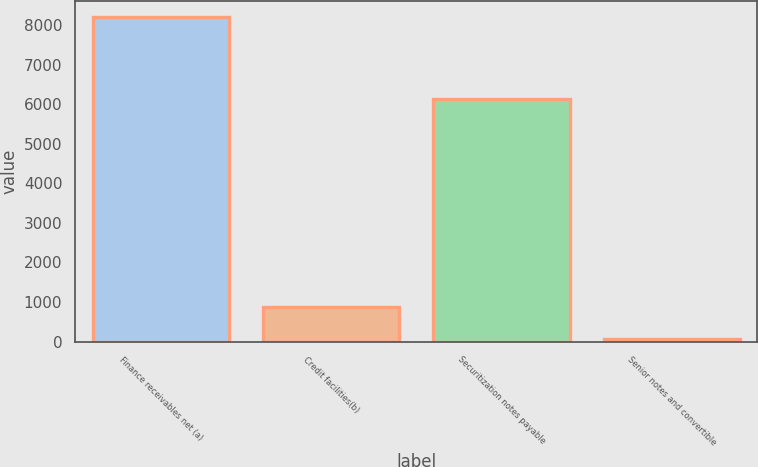Convert chart to OTSL. <chart><loc_0><loc_0><loc_500><loc_500><bar_chart><fcel>Finance receivables net (a)<fcel>Credit facilities(b)<fcel>Securitization notes payable<fcel>Senior notes and convertible<nl><fcel>8197<fcel>884.5<fcel>6128<fcel>72<nl></chart> 